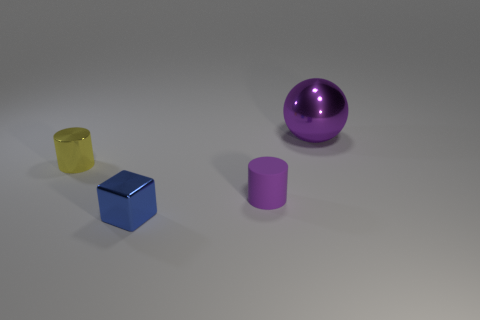What is the shape of the big thing that is made of the same material as the small yellow cylinder?
Make the answer very short. Sphere. What number of other objects are there of the same shape as the big thing?
Keep it short and to the point. 0. There is a tiny cube; how many small blue things are on the left side of it?
Give a very brief answer. 0. There is a shiny thing that is left of the tiny blue metallic block; is its size the same as the purple thing that is in front of the yellow cylinder?
Give a very brief answer. Yes. How many other objects are there of the same size as the purple shiny thing?
Make the answer very short. 0. What is the purple thing that is in front of the yellow metal object that is left of the cylinder on the right side of the blue metal thing made of?
Your answer should be compact. Rubber. There is a yellow cylinder; is its size the same as the object that is in front of the rubber cylinder?
Offer a terse response. Yes. There is a metallic object that is both behind the shiny block and right of the tiny yellow cylinder; what is its size?
Make the answer very short. Large. Is there another small metal cylinder of the same color as the metal cylinder?
Offer a very short reply. No. What color is the tiny thing left of the metallic thing in front of the purple matte object?
Your answer should be very brief. Yellow. 